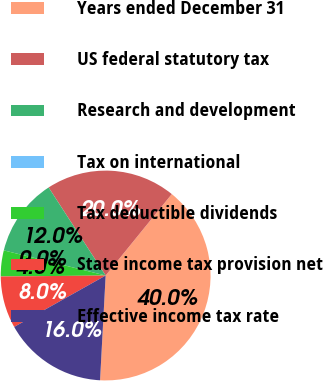<chart> <loc_0><loc_0><loc_500><loc_500><pie_chart><fcel>Years ended December 31<fcel>US federal statutory tax<fcel>Research and development<fcel>Tax on international<fcel>Tax deductible dividends<fcel>State income tax provision net<fcel>Effective income tax rate<nl><fcel>39.99%<fcel>20.0%<fcel>12.0%<fcel>0.0%<fcel>4.0%<fcel>8.0%<fcel>16.0%<nl></chart> 